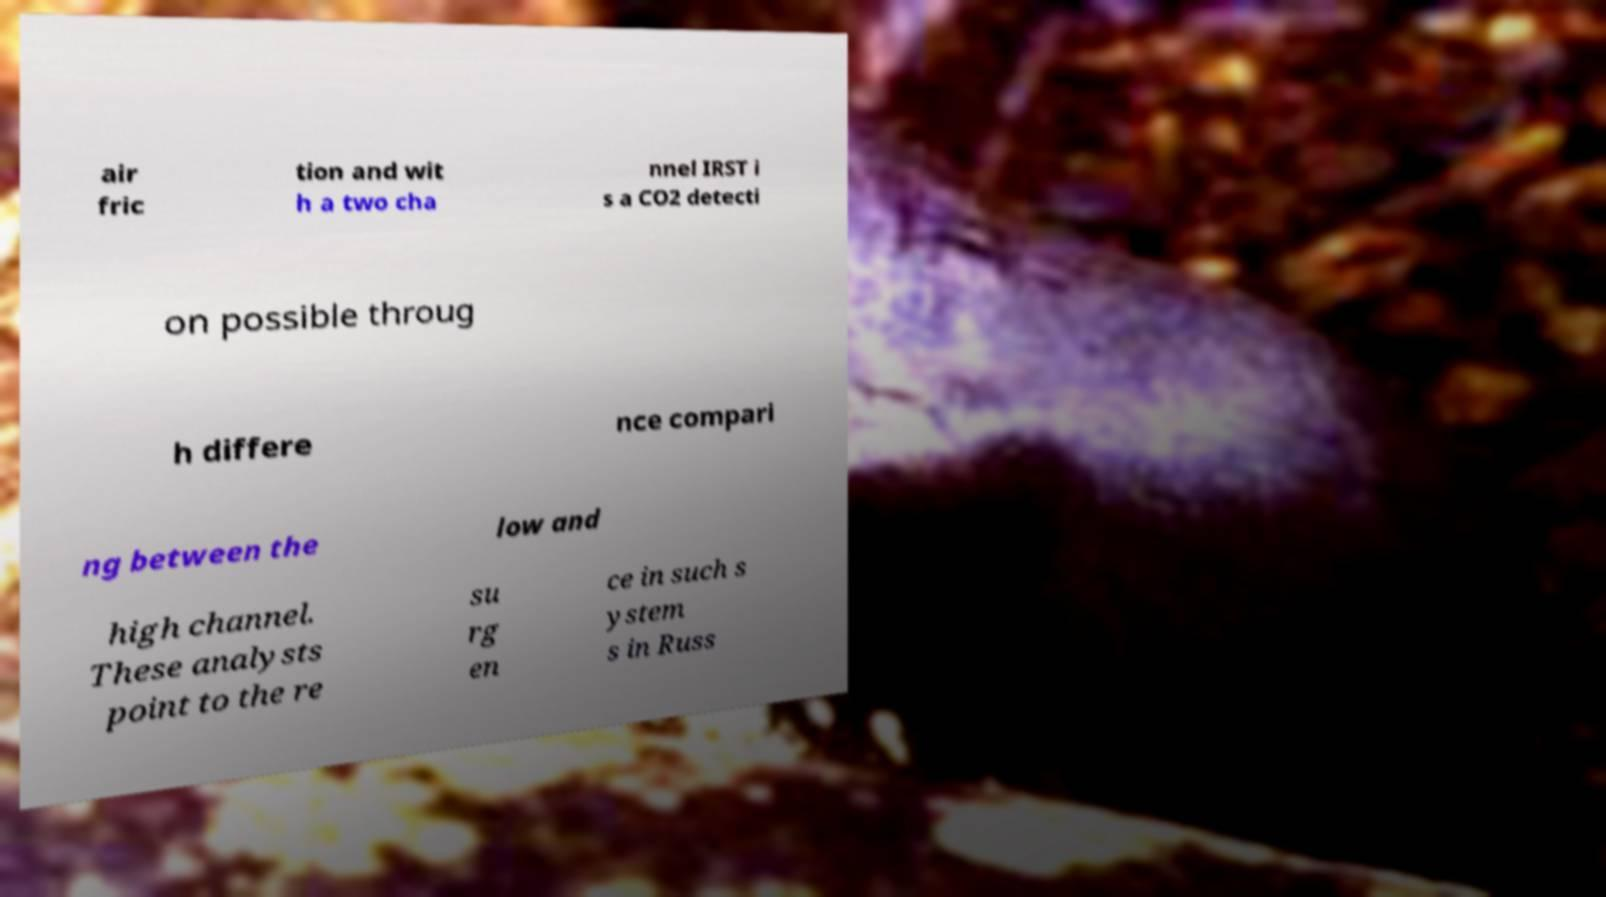Could you extract and type out the text from this image? air fric tion and wit h a two cha nnel IRST i s a CO2 detecti on possible throug h differe nce compari ng between the low and high channel. These analysts point to the re su rg en ce in such s ystem s in Russ 